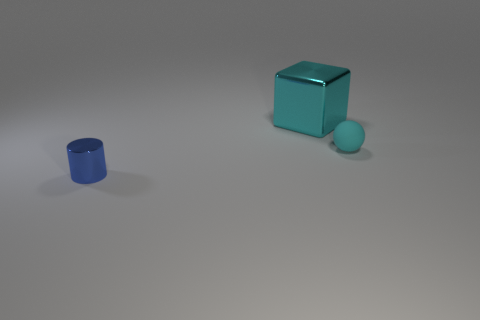Add 1 purple shiny cylinders. How many objects exist? 4 Subtract all balls. How many objects are left? 2 Add 2 small blue objects. How many small blue objects are left? 3 Add 1 rubber objects. How many rubber objects exist? 2 Subtract 0 gray cylinders. How many objects are left? 3 Subtract all small spheres. Subtract all big shiny things. How many objects are left? 1 